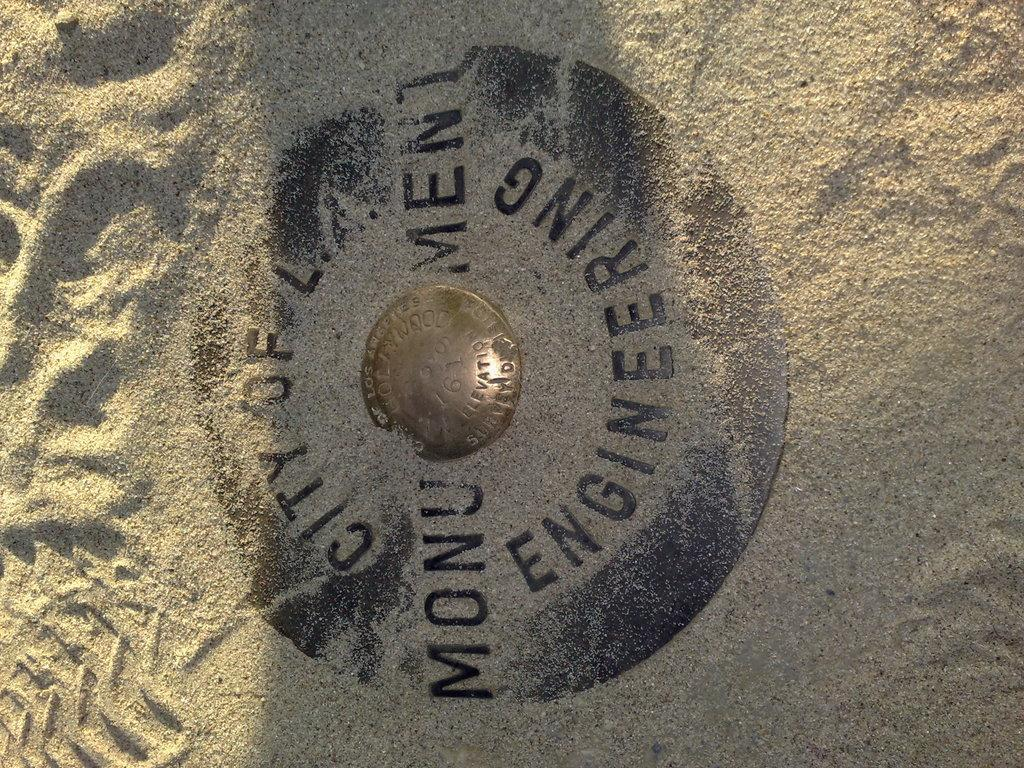<image>
Render a clear and concise summary of the photo. The sign covered in sand is about engineering monument. 